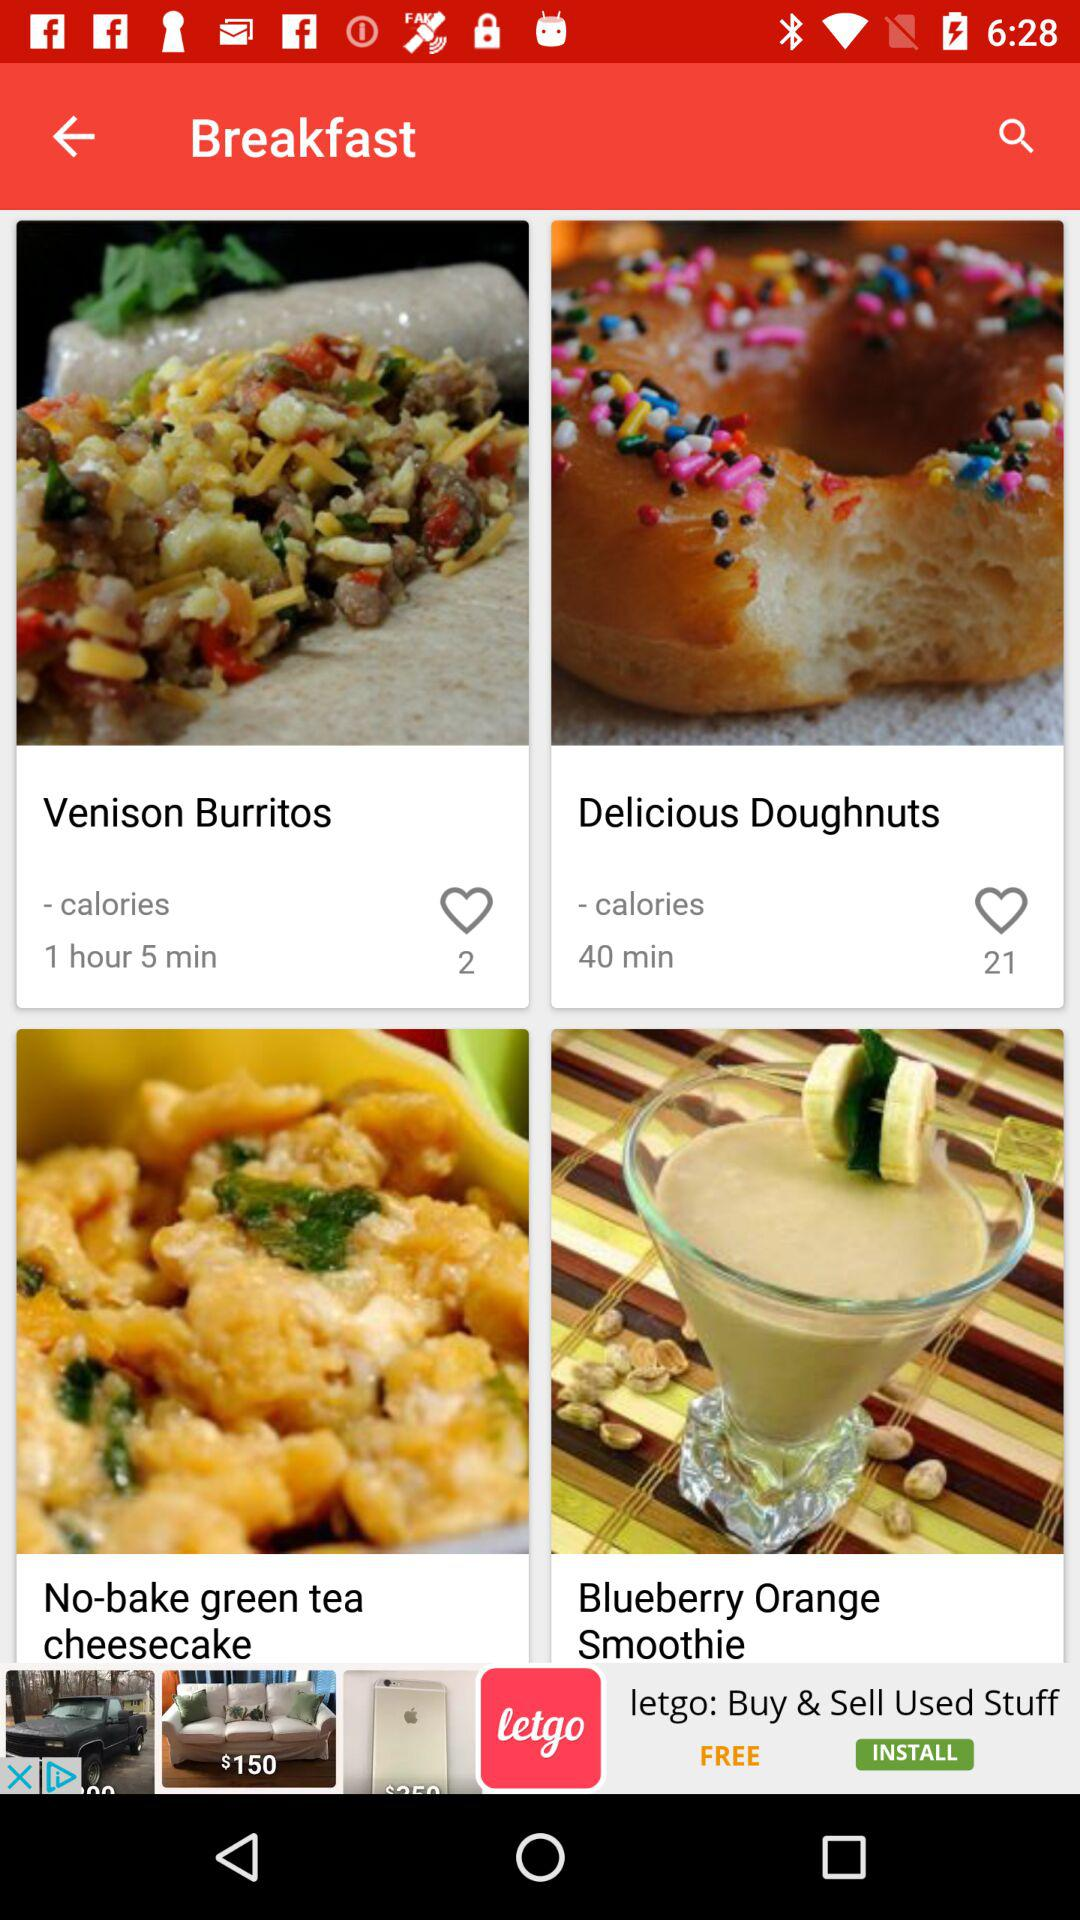How many likes are there on venison burritos? There are 2 likes on venison burritos. 